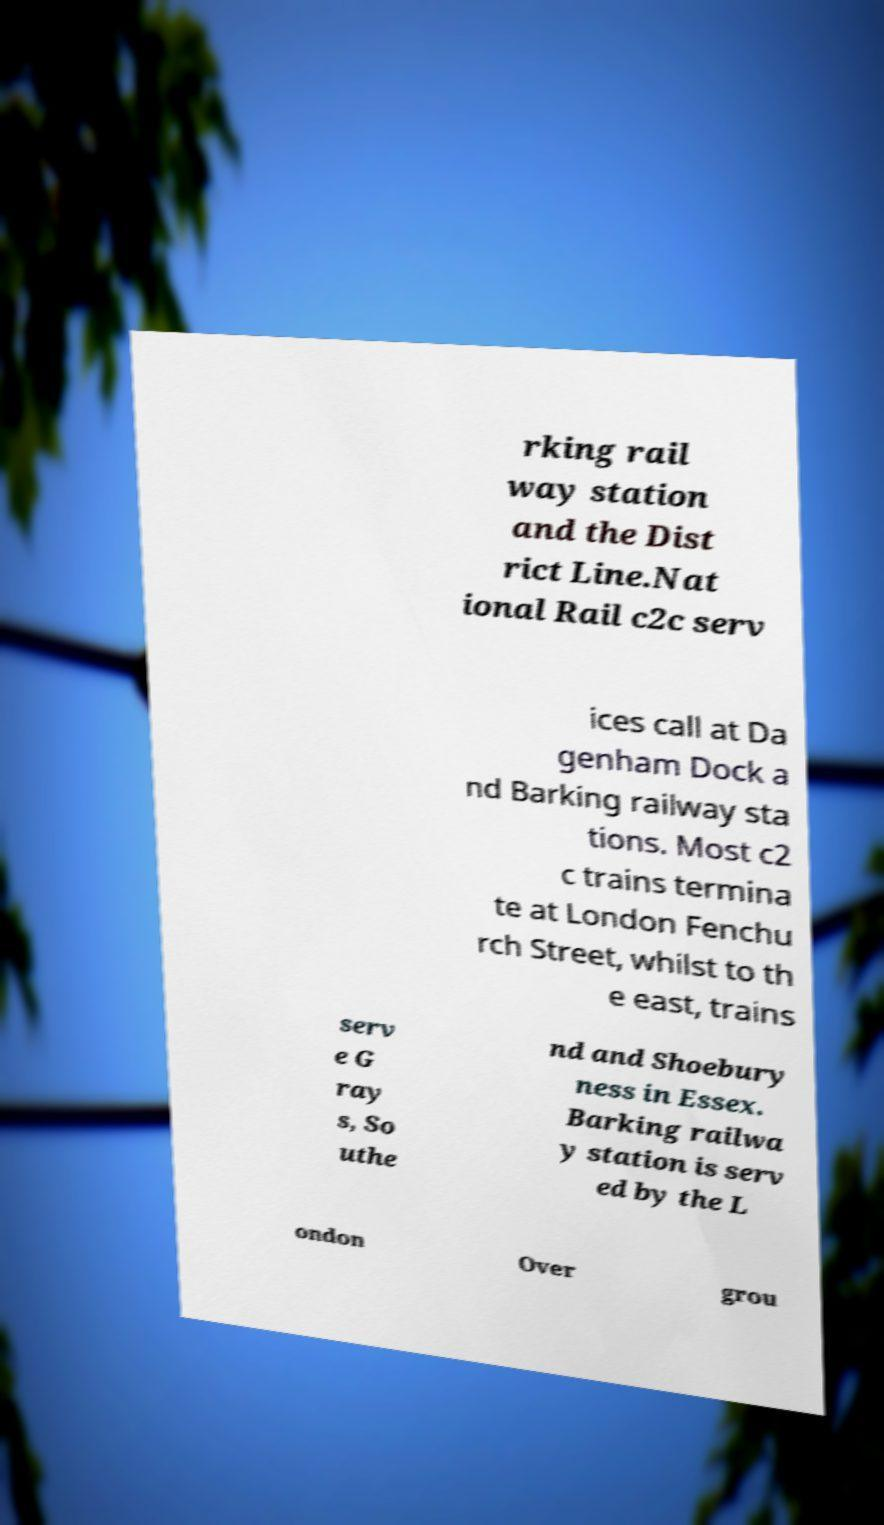Can you accurately transcribe the text from the provided image for me? rking rail way station and the Dist rict Line.Nat ional Rail c2c serv ices call at Da genham Dock a nd Barking railway sta tions. Most c2 c trains termina te at London Fenchu rch Street, whilst to th e east, trains serv e G ray s, So uthe nd and Shoebury ness in Essex. Barking railwa y station is serv ed by the L ondon Over grou 